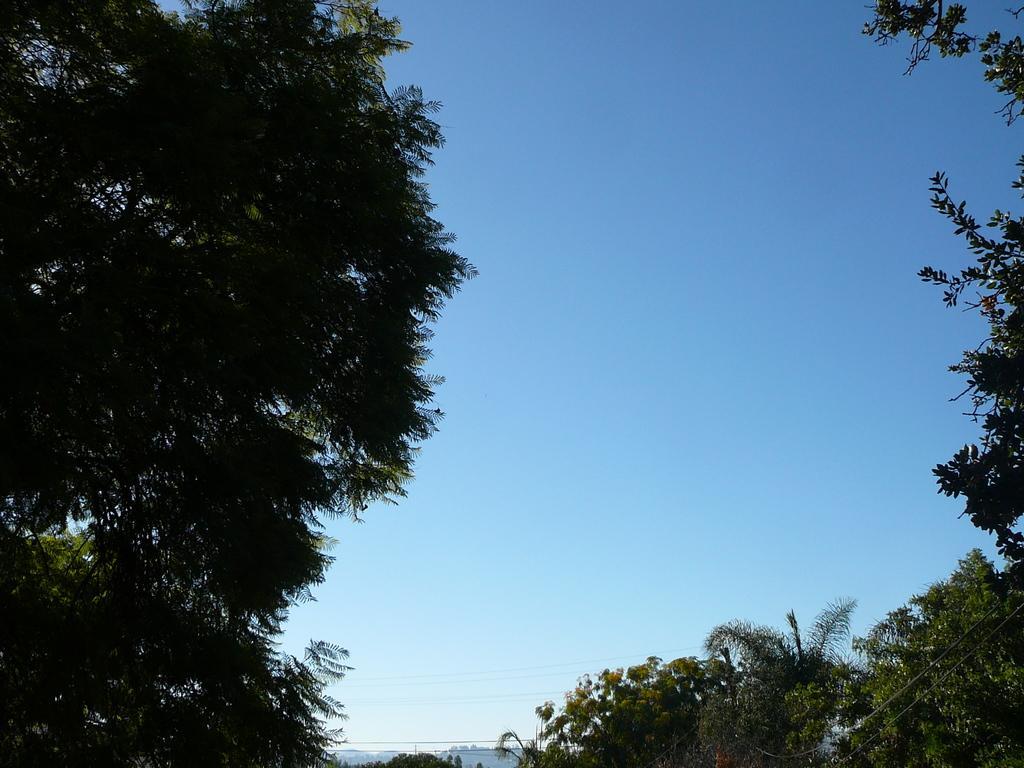Can you describe this image briefly? At the bottom of the image we can see the wires, poles and hills. In the background of the image we can see the trees. At the top of the image we can see the sky. 